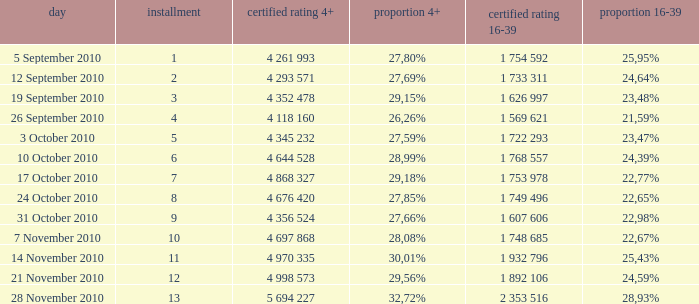What is the official 4+ rating of the episode with a 16-39 share of 24,59%? 4 998 573. Could you help me parse every detail presented in this table? {'header': ['day', 'installment', 'certified rating 4+', 'proportion 4+', 'certified rating 16-39', 'proportion 16-39'], 'rows': [['5 September 2010', '1', '4 261 993', '27,80%', '1 754 592', '25,95%'], ['12 September 2010', '2', '4 293 571', '27,69%', '1 733 311', '24,64%'], ['19 September 2010', '3', '4 352 478', '29,15%', '1 626 997', '23,48%'], ['26 September 2010', '4', '4 118 160', '26,26%', '1 569 621', '21,59%'], ['3 October 2010', '5', '4 345 232', '27,59%', '1 722 293', '23,47%'], ['10 October 2010', '6', '4 644 528', '28,99%', '1 768 557', '24,39%'], ['17 October 2010', '7', '4 868 327', '29,18%', '1 753 978', '22,77%'], ['24 October 2010', '8', '4 676 420', '27,85%', '1 749 496', '22,65%'], ['31 October 2010', '9', '4 356 524', '27,66%', '1 607 606', '22,98%'], ['7 November 2010', '10', '4 697 868', '28,08%', '1 748 685', '22,67%'], ['14 November 2010', '11', '4 970 335', '30,01%', '1 932 796', '25,43%'], ['21 November 2010', '12', '4 998 573', '29,56%', '1 892 106', '24,59%'], ['28 November 2010', '13', '5 694 227', '32,72%', '2 353 516', '28,93%']]} 